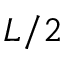Convert formula to latex. <formula><loc_0><loc_0><loc_500><loc_500>L / 2</formula> 